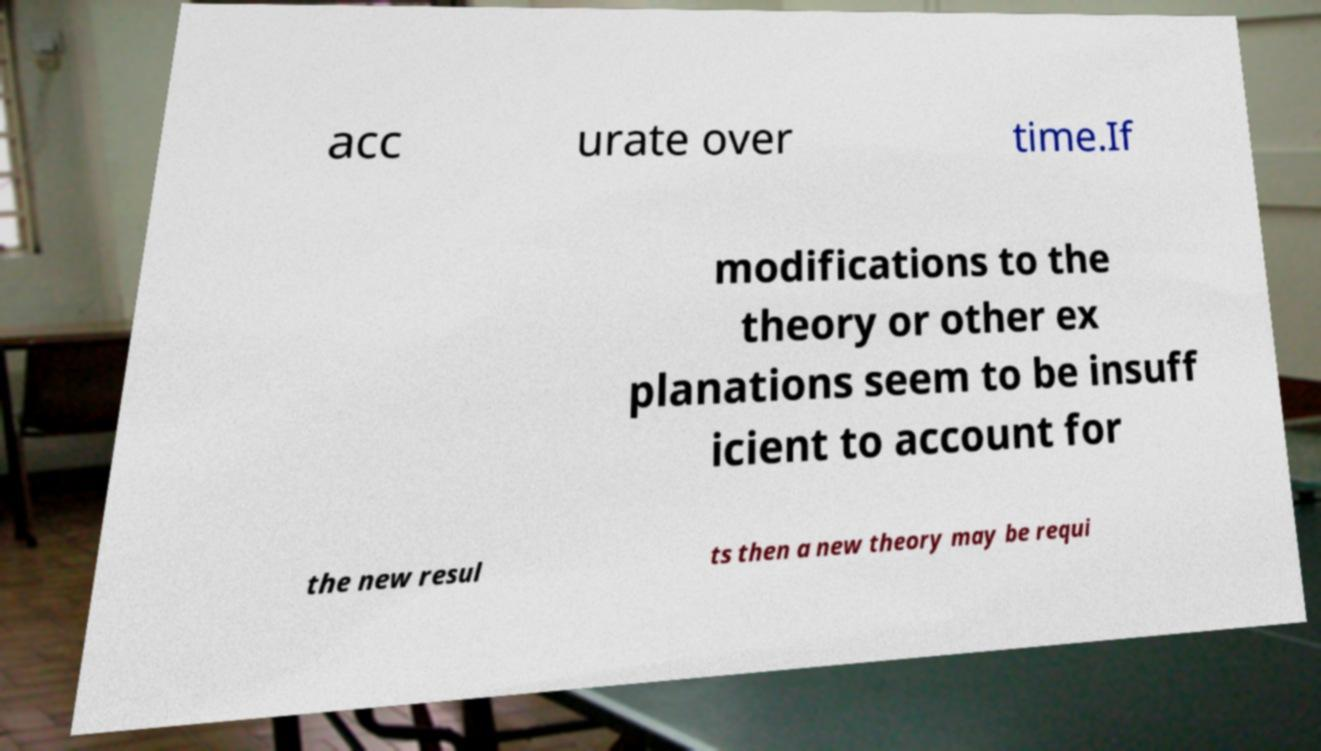Can you read and provide the text displayed in the image?This photo seems to have some interesting text. Can you extract and type it out for me? acc urate over time.If modifications to the theory or other ex planations seem to be insuff icient to account for the new resul ts then a new theory may be requi 